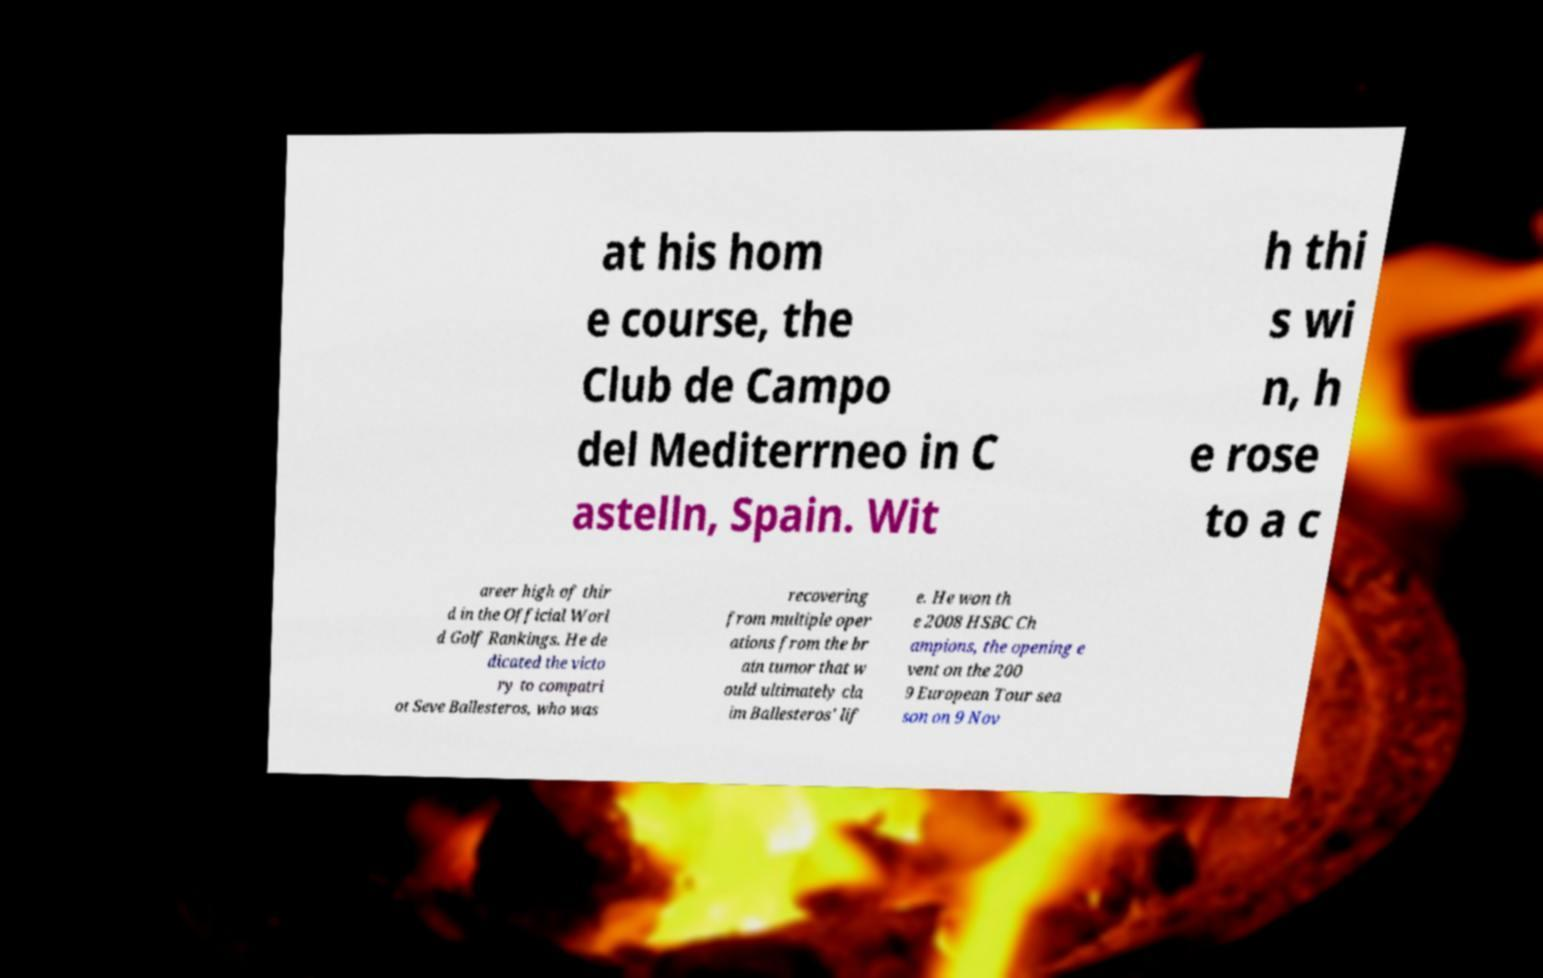Can you read and provide the text displayed in the image?This photo seems to have some interesting text. Can you extract and type it out for me? at his hom e course, the Club de Campo del Mediterrneo in C astelln, Spain. Wit h thi s wi n, h e rose to a c areer high of thir d in the Official Worl d Golf Rankings. He de dicated the victo ry to compatri ot Seve Ballesteros, who was recovering from multiple oper ations from the br ain tumor that w ould ultimately cla im Ballesteros' lif e. He won th e 2008 HSBC Ch ampions, the opening e vent on the 200 9 European Tour sea son on 9 Nov 